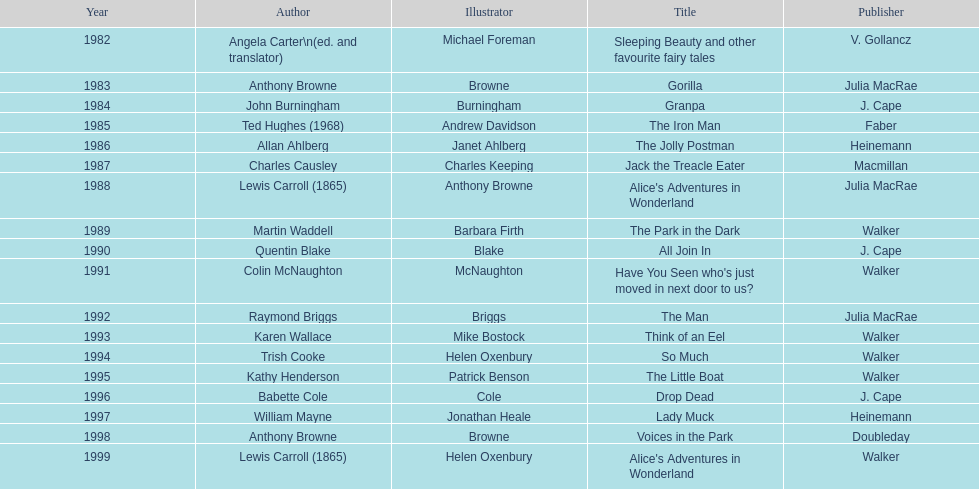How many titles featured the same author as the illustrator? 7. 